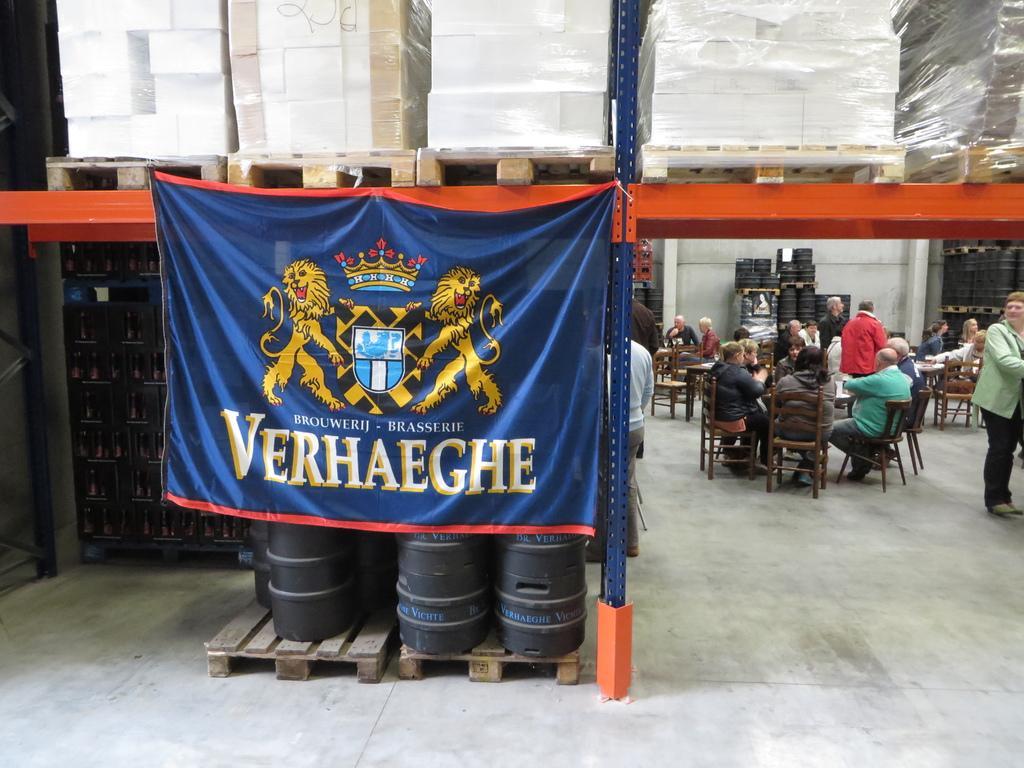Can you describe this image briefly? In this image I can see a banner. To the right of that banner there are group of people sitting on the chairs and two people are standing. At the back there are some drums. 